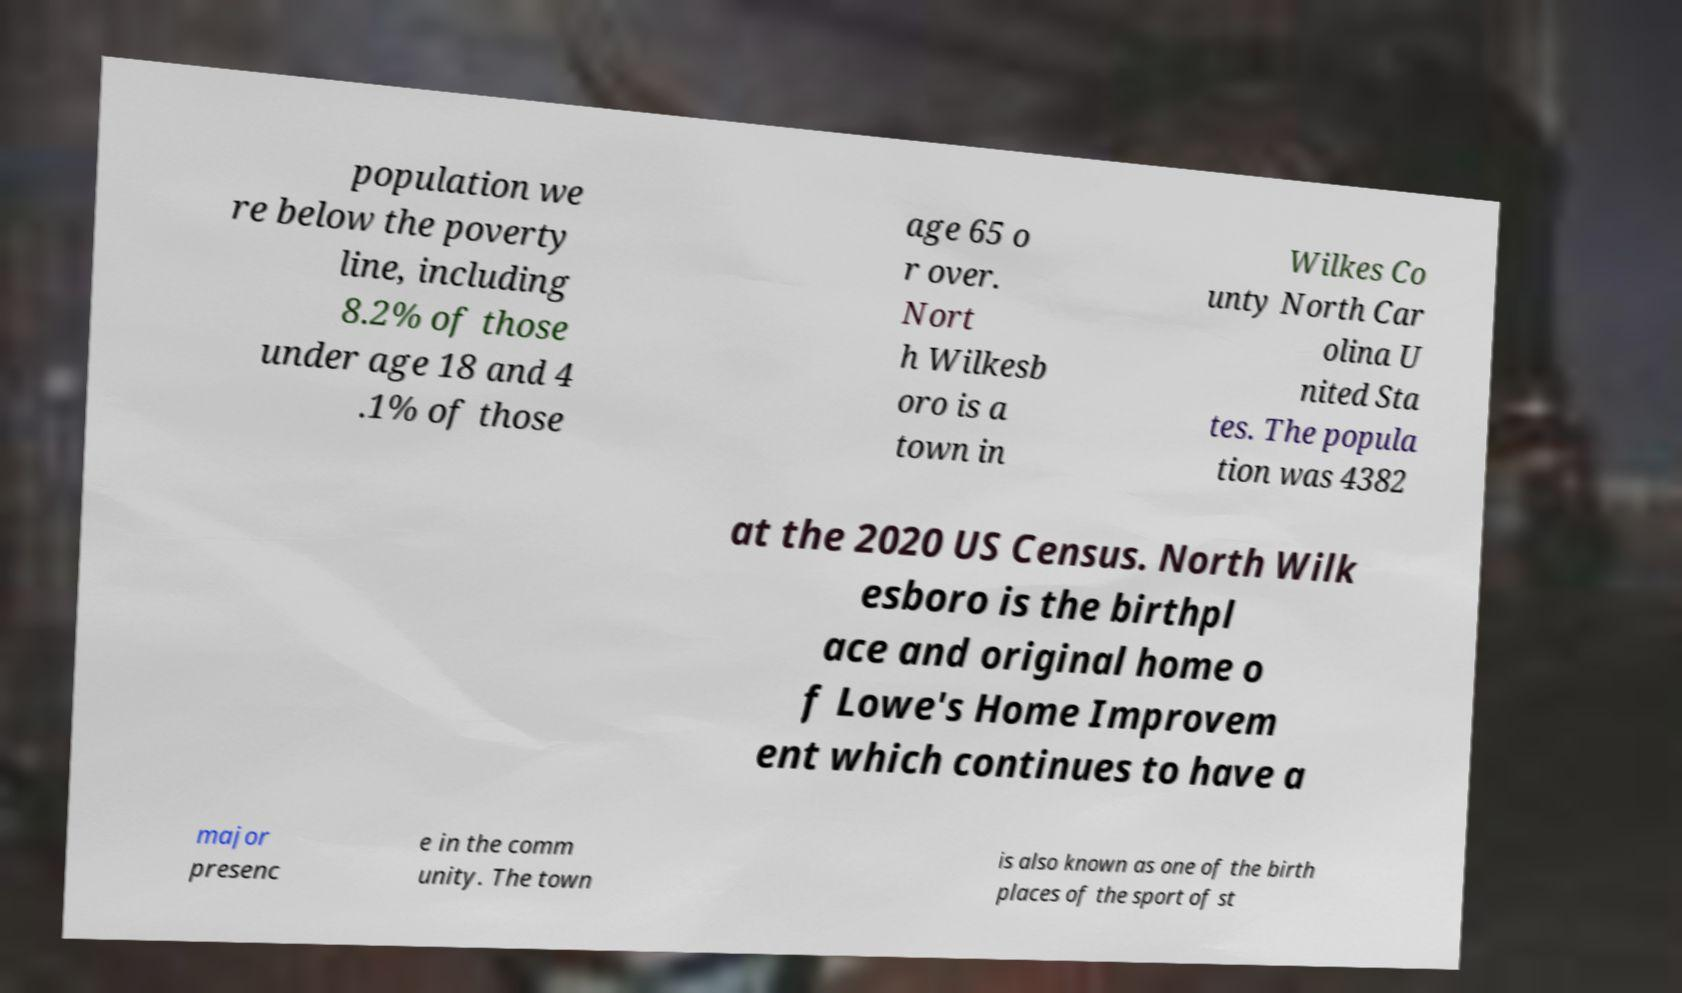Can you read and provide the text displayed in the image?This photo seems to have some interesting text. Can you extract and type it out for me? population we re below the poverty line, including 8.2% of those under age 18 and 4 .1% of those age 65 o r over. Nort h Wilkesb oro is a town in Wilkes Co unty North Car olina U nited Sta tes. The popula tion was 4382 at the 2020 US Census. North Wilk esboro is the birthpl ace and original home o f Lowe's Home Improvem ent which continues to have a major presenc e in the comm unity. The town is also known as one of the birth places of the sport of st 